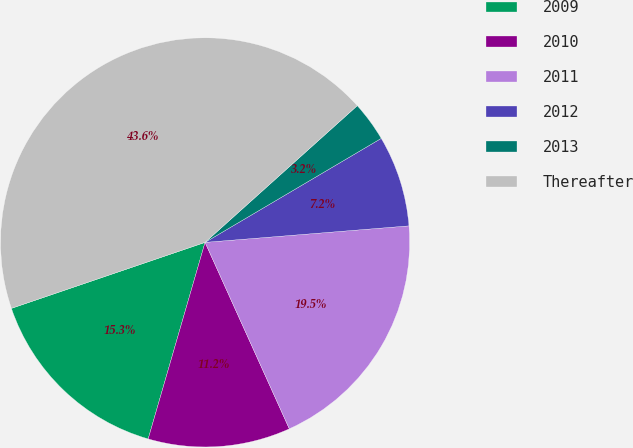Convert chart to OTSL. <chart><loc_0><loc_0><loc_500><loc_500><pie_chart><fcel>2009<fcel>2010<fcel>2011<fcel>2012<fcel>2013<fcel>Thereafter<nl><fcel>15.29%<fcel>11.24%<fcel>19.53%<fcel>7.2%<fcel>3.16%<fcel>43.58%<nl></chart> 